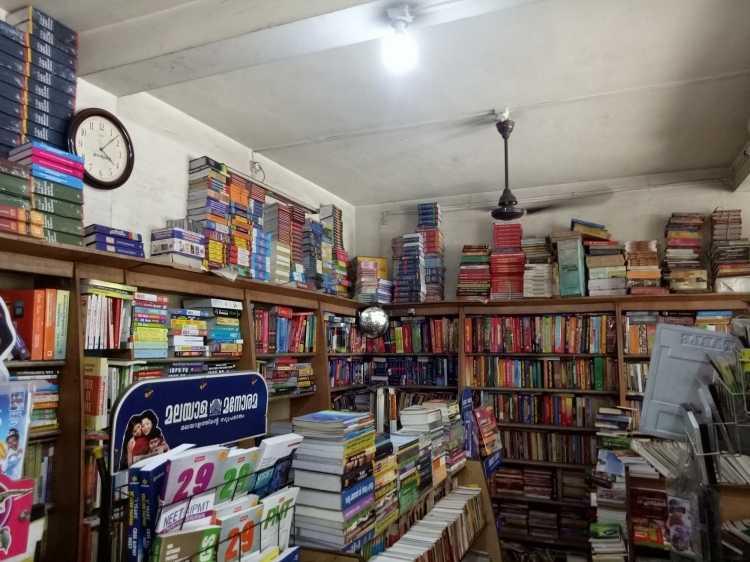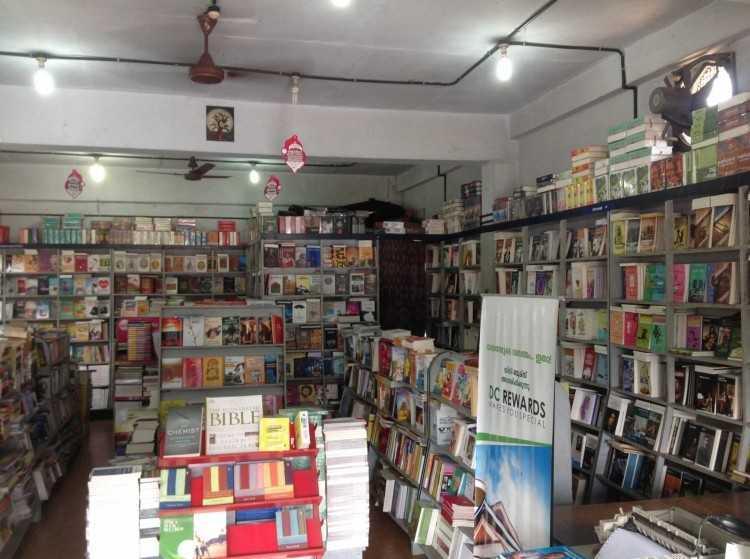The first image is the image on the left, the second image is the image on the right. Examine the images to the left and right. Is the description "A bookstore image includes a green balloon and a variety of green signage." accurate? Answer yes or no. No. 